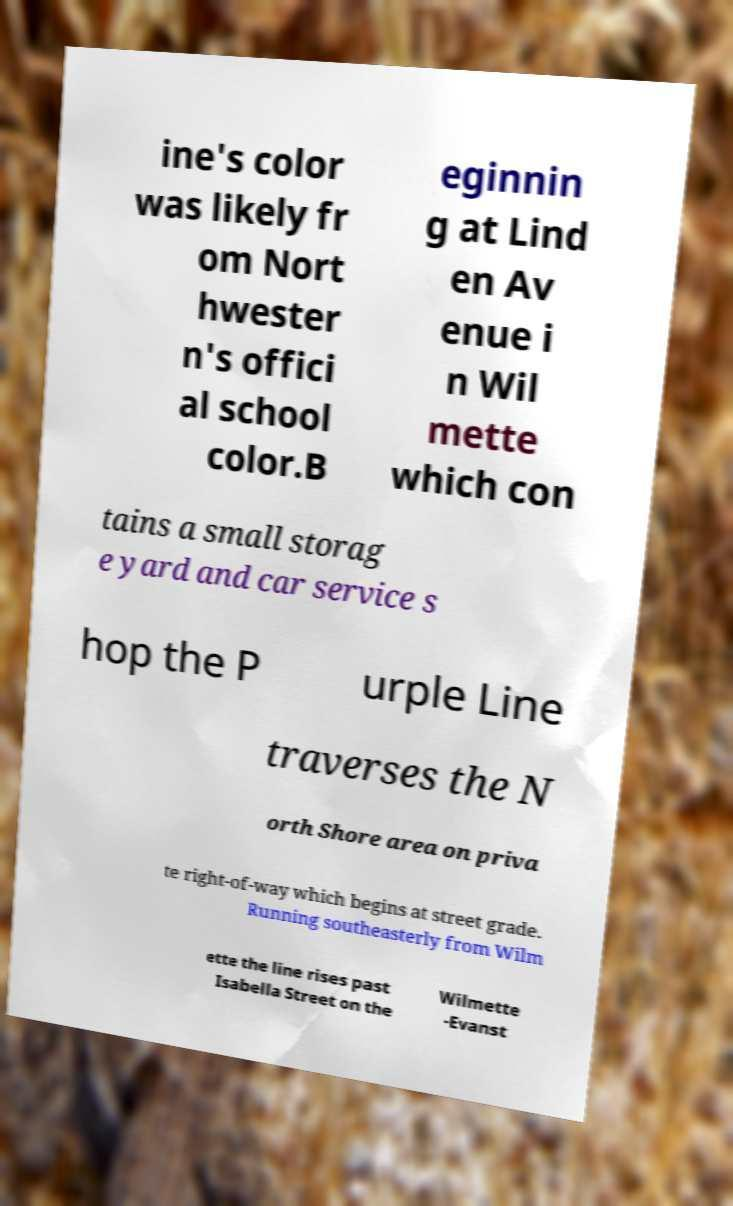For documentation purposes, I need the text within this image transcribed. Could you provide that? ine's color was likely fr om Nort hwester n's offici al school color.B eginnin g at Lind en Av enue i n Wil mette which con tains a small storag e yard and car service s hop the P urple Line traverses the N orth Shore area on priva te right-of-way which begins at street grade. Running southeasterly from Wilm ette the line rises past Isabella Street on the Wilmette -Evanst 